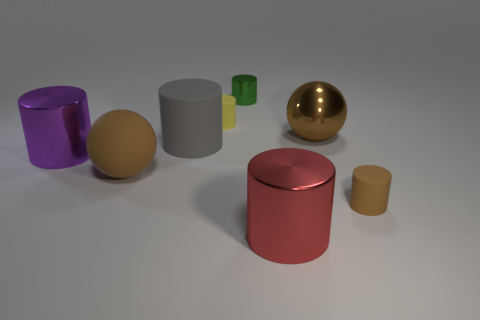Subtract all purple cylinders. How many cylinders are left? 5 Add 1 tiny yellow rubber things. How many objects exist? 9 Subtract all green cylinders. How many cylinders are left? 5 Subtract 1 spheres. How many spheres are left? 1 Subtract all cylinders. How many objects are left? 2 Subtract all red cylinders. Subtract all brown spheres. How many cylinders are left? 5 Subtract all yellow matte cylinders. Subtract all large rubber balls. How many objects are left? 6 Add 1 green shiny things. How many green shiny things are left? 2 Add 5 small metallic things. How many small metallic things exist? 6 Subtract 1 green cylinders. How many objects are left? 7 